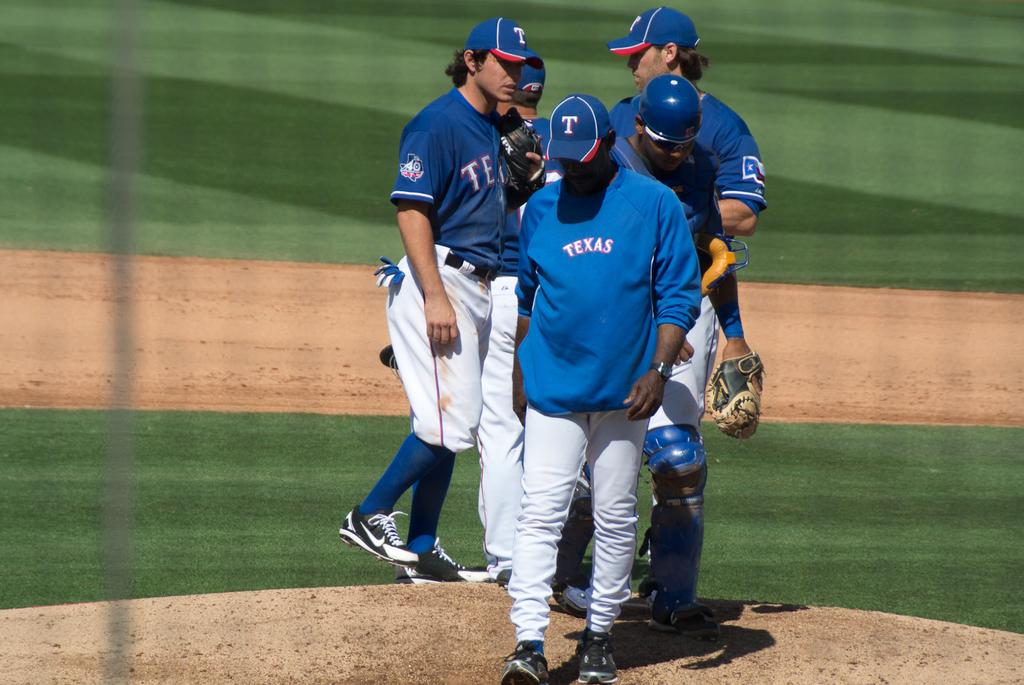<image>
Offer a succinct explanation of the picture presented. a coach that has the word texas on their sweatshirt 